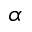Convert formula to latex. <formula><loc_0><loc_0><loc_500><loc_500>\alpha</formula> 